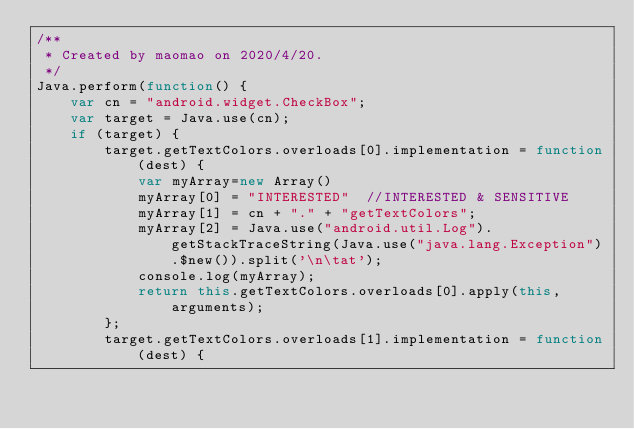Convert code to text. <code><loc_0><loc_0><loc_500><loc_500><_JavaScript_>/**
 * Created by maomao on 2020/4/20.
 */
Java.perform(function() {
    var cn = "android.widget.CheckBox";
    var target = Java.use(cn);
    if (target) {
        target.getTextColors.overloads[0].implementation = function(dest) {
            var myArray=new Array()
            myArray[0] = "INTERESTED"  //INTERESTED & SENSITIVE
            myArray[1] = cn + "." + "getTextColors";
            myArray[2] = Java.use("android.util.Log").getStackTraceString(Java.use("java.lang.Exception").$new()).split('\n\tat');
            console.log(myArray);
            return this.getTextColors.overloads[0].apply(this, arguments);
        };
        target.getTextColors.overloads[1].implementation = function(dest) {</code> 